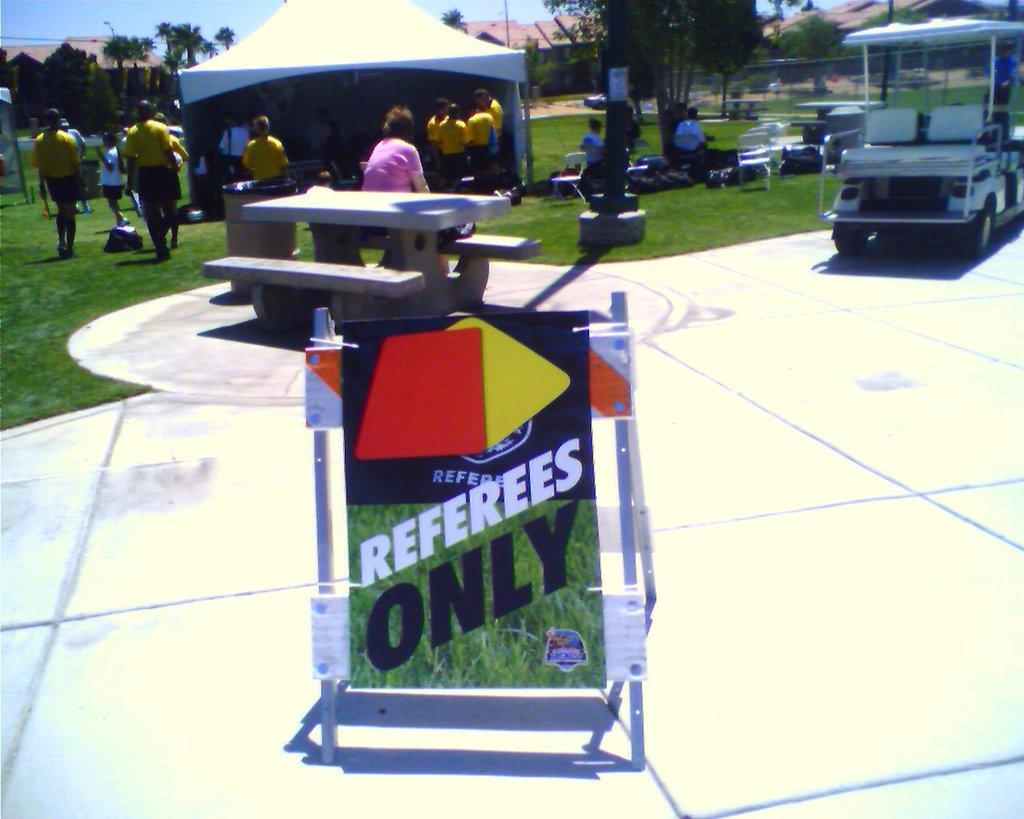Who is only allowed here?
Keep it short and to the point. Referees. Is there players allowed ?
Ensure brevity in your answer.  No. 